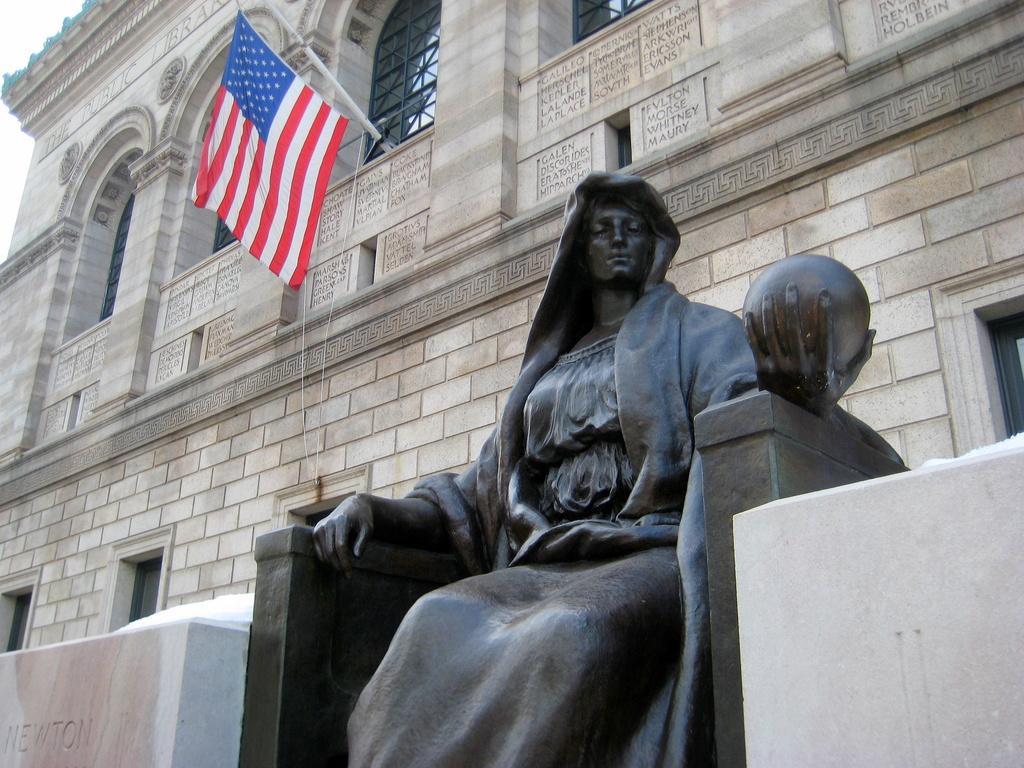Please provide a concise description of this image. In the middle of the image there is a statue of the lady is in sitting position. And to the left and right bottom of the image there are walls. And in the background there is a building with brick walls, pole with flag, pillars and glass windows. 